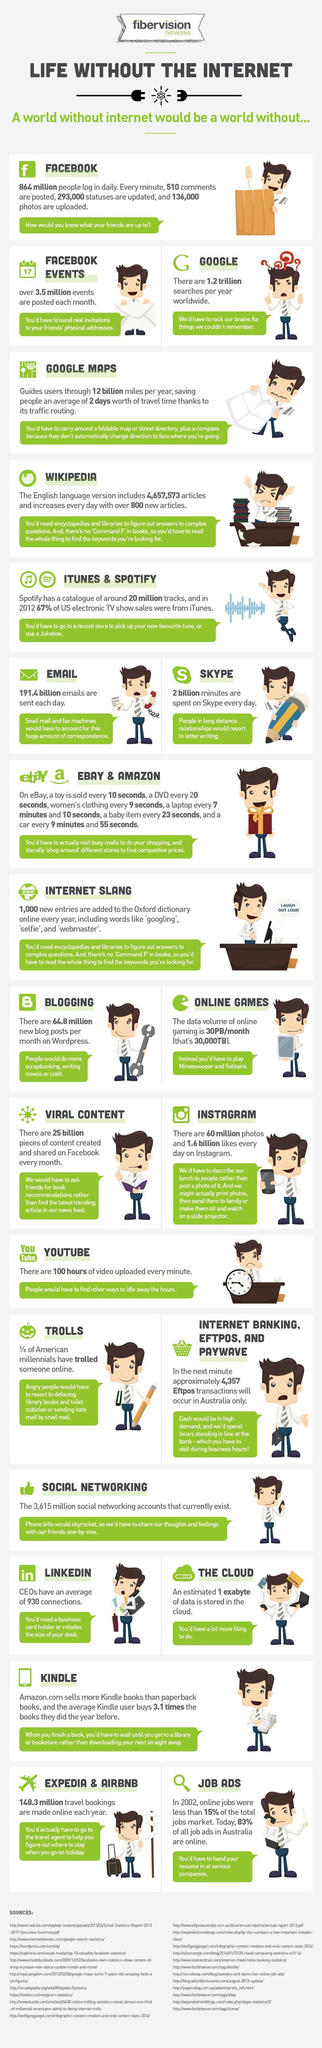Draw attention to some important aspects in this diagram. Wikipedia adds approximately 800 articles to its platform every 24 hours. According to recent data, approximately 3.5 million photo uploads occur on Facebook in a month. According to recent data, a significant portion of current job advertisements in Australia are not published online. 